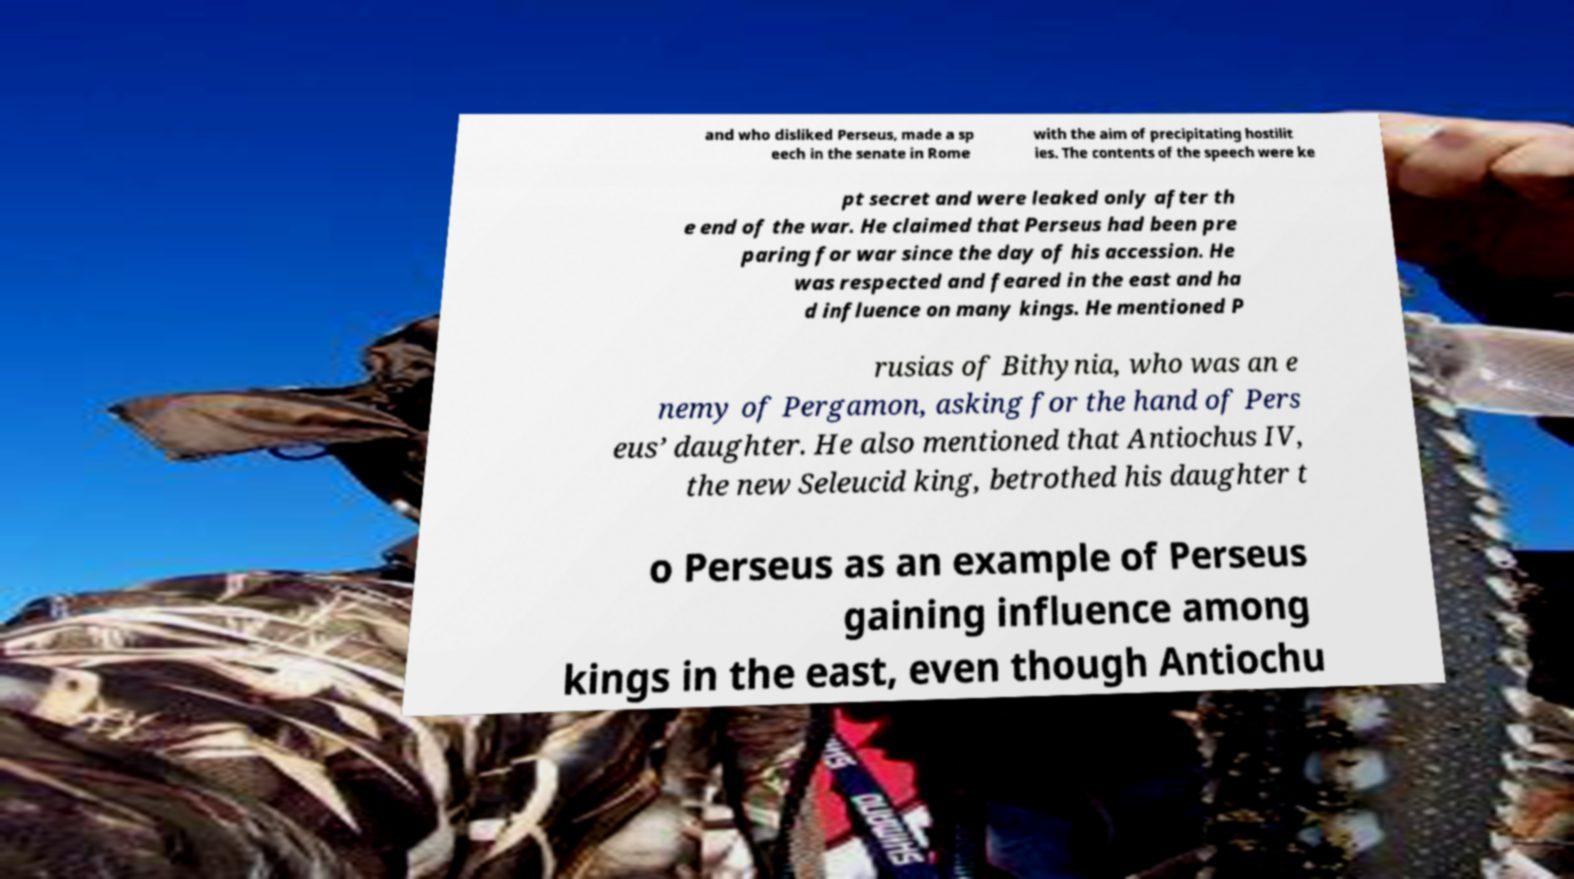Can you accurately transcribe the text from the provided image for me? and who disliked Perseus, made a sp eech in the senate in Rome with the aim of precipitating hostilit ies. The contents of the speech were ke pt secret and were leaked only after th e end of the war. He claimed that Perseus had been pre paring for war since the day of his accession. He was respected and feared in the east and ha d influence on many kings. He mentioned P rusias of Bithynia, who was an e nemy of Pergamon, asking for the hand of Pers eus’ daughter. He also mentioned that Antiochus IV, the new Seleucid king, betrothed his daughter t o Perseus as an example of Perseus gaining influence among kings in the east, even though Antiochu 